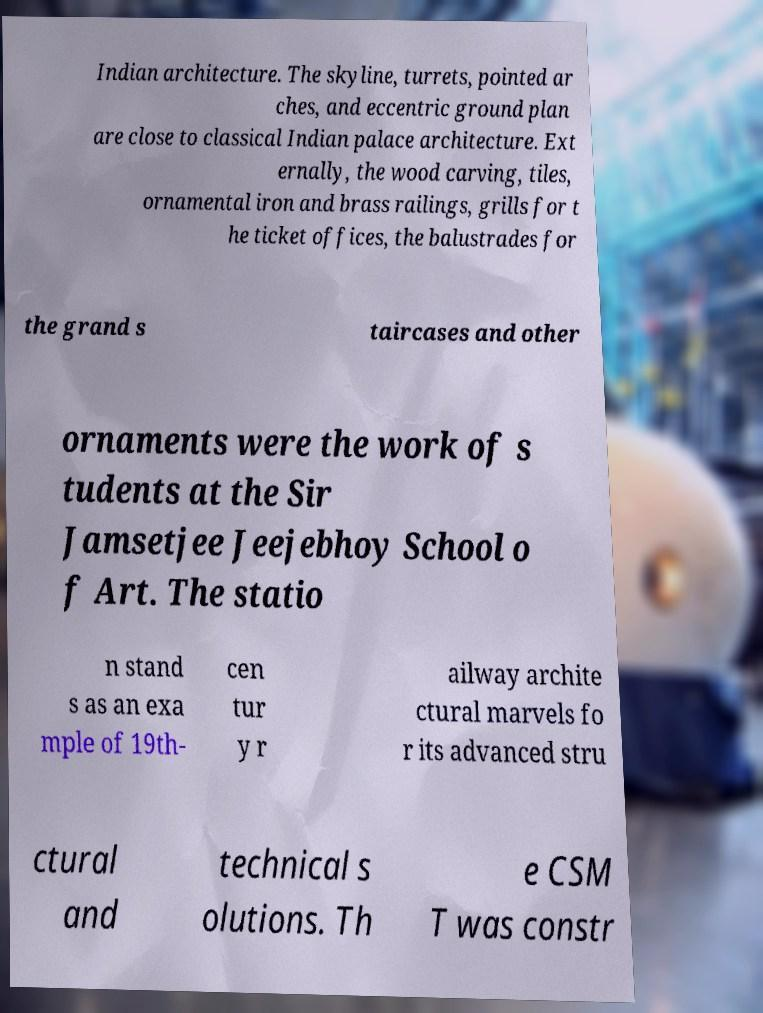Could you extract and type out the text from this image? Indian architecture. The skyline, turrets, pointed ar ches, and eccentric ground plan are close to classical Indian palace architecture. Ext ernally, the wood carving, tiles, ornamental iron and brass railings, grills for t he ticket offices, the balustrades for the grand s taircases and other ornaments were the work of s tudents at the Sir Jamsetjee Jeejebhoy School o f Art. The statio n stand s as an exa mple of 19th- cen tur y r ailway archite ctural marvels fo r its advanced stru ctural and technical s olutions. Th e CSM T was constr 